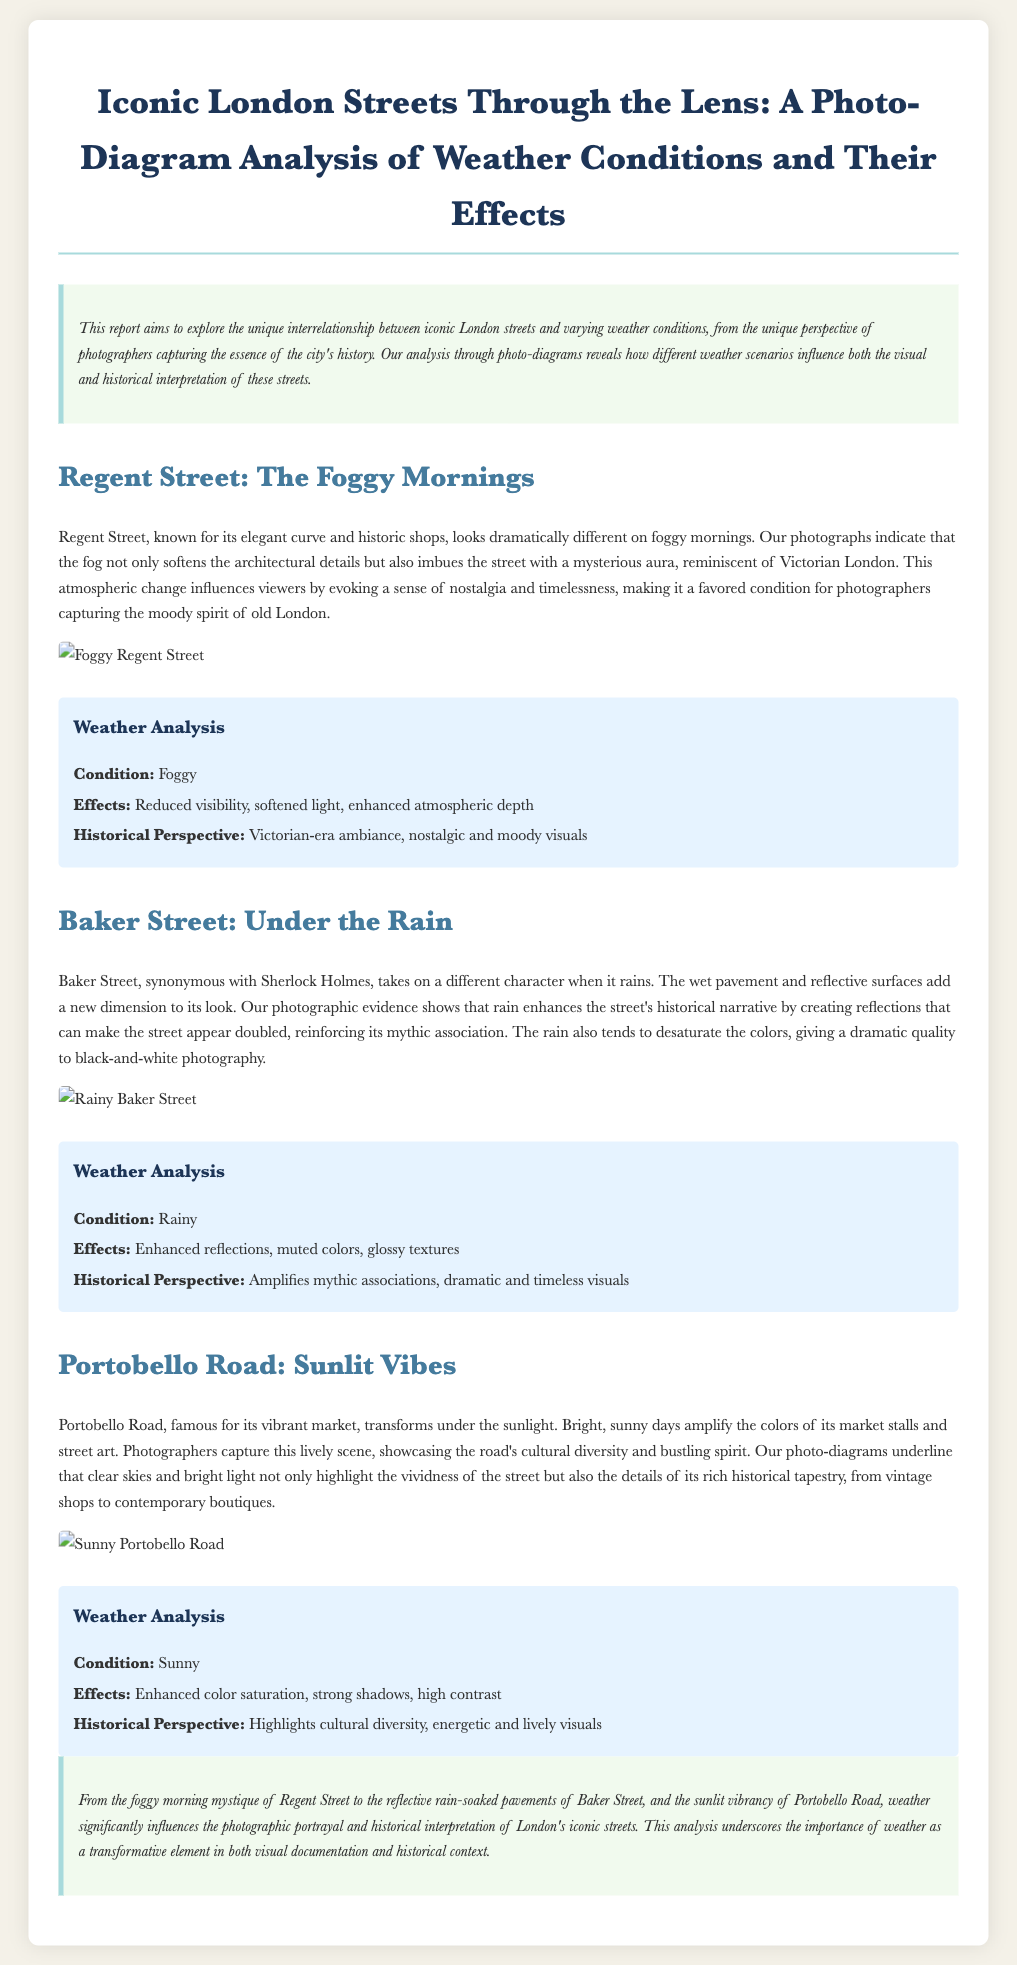What is the title of the report? The title is explicitly stated at the top of the document, serving as the main heading.
Answer: Iconic London Streets Through the Lens: A Photo-Diagram Analysis of Weather Conditions and Their Effects What weather condition is described for Regent Street? The specific weather condition is mentioned in the section dedicated to Regent Street.
Answer: Foggy What type of perspectives does Baker Street's rainy weather evoke? The document directly states how the rainy condition impacts visual and historical perspectives in Baker Street.
Answer: Mythic associations What effect does sunshine have on Portobello Road? The report outlines the specific effects of sunny weather on Portobello Road in the corresponding section.
Answer: Enhanced color saturation Which street is associated with Sherlock Holmes? The document explicitly names the street that has this cultural association.
Answer: Baker Street What is the mood conveyed by fog in Regent Street? The report describes the emotional and visual essence produced by foggy conditions regarding the street.
Answer: Nostalgic and moody How does rain affect color in photographs of Baker Street? The document states the impact of rain on color saturation and visual quality in photographs.
Answer: Muted colors What is the visual outcome of sunny days in Portobello Road? The report explains how weather conditions impact the visual representation of the street under sunlight.
Answer: Strong shadows What component greatly influences the photographic portrayal of London streets? The report highlights a key factor that affects both visual documentation and historical context in its analysis.
Answer: Weather 